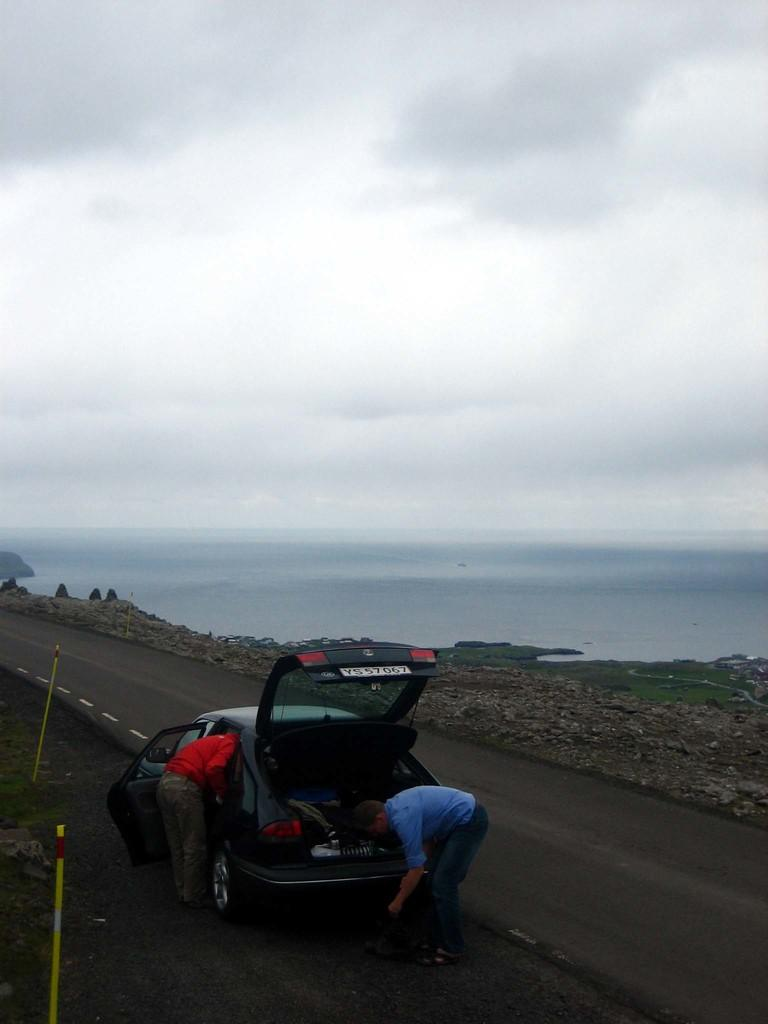How many people are in the image? There are two persons in the image. What is present on the road in the image? There is a vehicle on the road in the image. What natural element can be seen in the image? Water is visible in the image. What is visible in the background of the image? The sky is visible in the background of the image. What degree of difficulty is the image rated on a scale of 1 to 10? The image is not rated on a scale of difficulty, as it is a visual representation and not a task or challenge. 